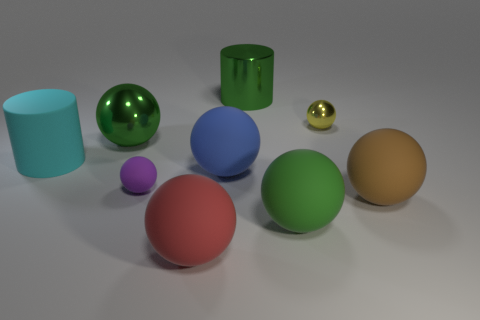Subtract all yellow balls. How many balls are left? 6 Add 1 small shiny spheres. How many objects exist? 10 Subtract all green balls. How many balls are left? 5 Subtract 0 yellow blocks. How many objects are left? 9 Subtract all balls. How many objects are left? 2 Subtract 2 spheres. How many spheres are left? 5 Subtract all blue cylinders. Subtract all brown spheres. How many cylinders are left? 2 Subtract all yellow cylinders. How many blue spheres are left? 1 Subtract all tiny brown shiny blocks. Subtract all large shiny spheres. How many objects are left? 8 Add 5 green matte spheres. How many green matte spheres are left? 6 